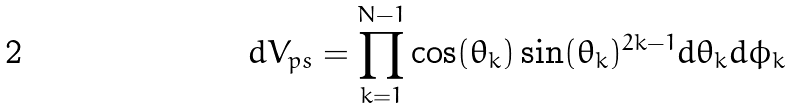Convert formula to latex. <formula><loc_0><loc_0><loc_500><loc_500>d V _ { p s } = \prod _ { k = 1 } ^ { N - 1 } \cos ( \theta _ { k } ) \sin ( \theta _ { k } ) ^ { 2 k - 1 } d \theta _ { k } d \phi _ { k }</formula> 